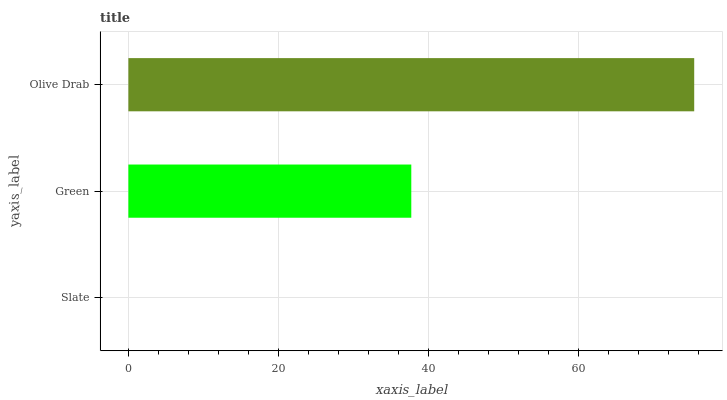Is Slate the minimum?
Answer yes or no. Yes. Is Olive Drab the maximum?
Answer yes or no. Yes. Is Green the minimum?
Answer yes or no. No. Is Green the maximum?
Answer yes or no. No. Is Green greater than Slate?
Answer yes or no. Yes. Is Slate less than Green?
Answer yes or no. Yes. Is Slate greater than Green?
Answer yes or no. No. Is Green less than Slate?
Answer yes or no. No. Is Green the high median?
Answer yes or no. Yes. Is Green the low median?
Answer yes or no. Yes. Is Slate the high median?
Answer yes or no. No. Is Olive Drab the low median?
Answer yes or no. No. 